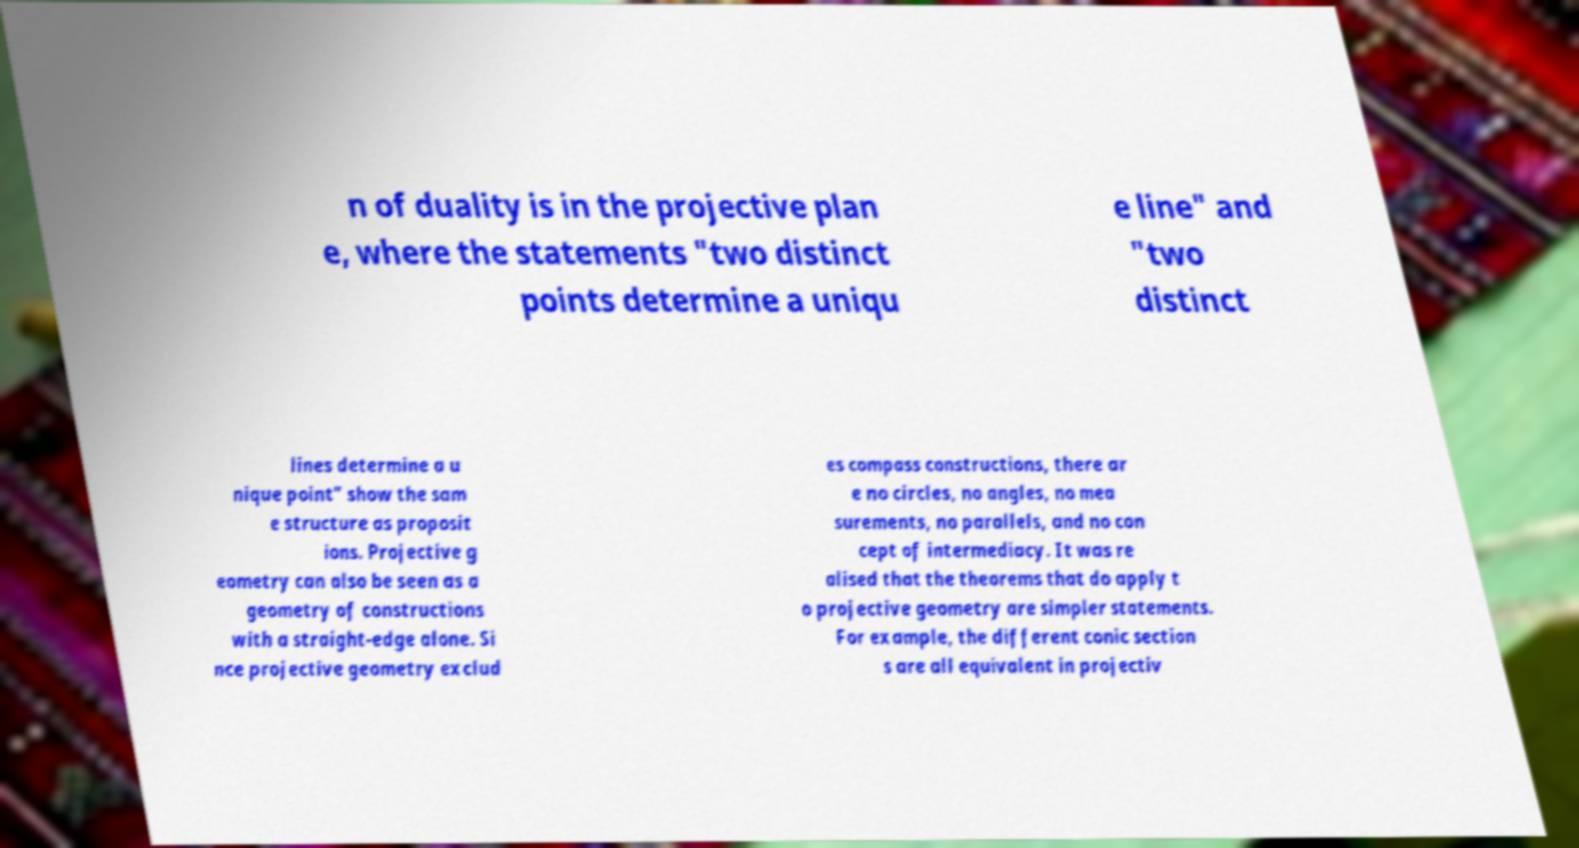There's text embedded in this image that I need extracted. Can you transcribe it verbatim? n of duality is in the projective plan e, where the statements "two distinct points determine a uniqu e line" and "two distinct lines determine a u nique point" show the sam e structure as proposit ions. Projective g eometry can also be seen as a geometry of constructions with a straight-edge alone. Si nce projective geometry exclud es compass constructions, there ar e no circles, no angles, no mea surements, no parallels, and no con cept of intermediacy. It was re alised that the theorems that do apply t o projective geometry are simpler statements. For example, the different conic section s are all equivalent in projectiv 